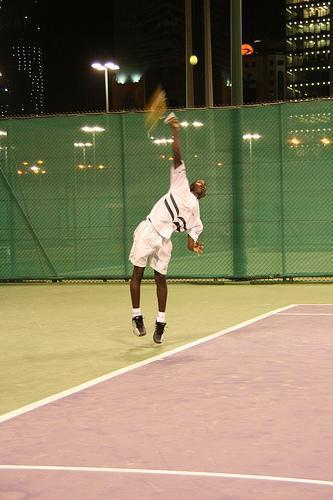How many people are in the picture?
Give a very brief answer. 1. 